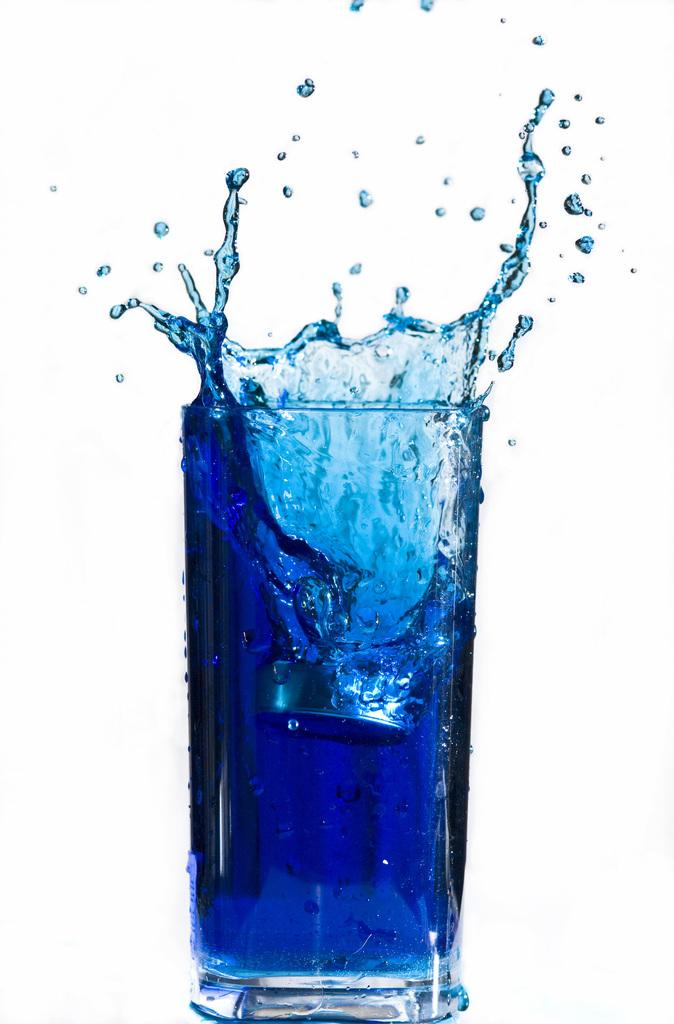What is inside the glass that is visible in the image? There is an object in the glass, and there is also a drink in the glass. Can you describe the object in the glass? Unfortunately, the facts provided do not give a description of the object in the glass. What is the color of the background in the image? The background of the image is white. How many kittens are playing with the object in the image? There are no kittens present in the image. What type of base is supporting the glass in the image? The facts provided do not mention any base supporting the glass in the image. 